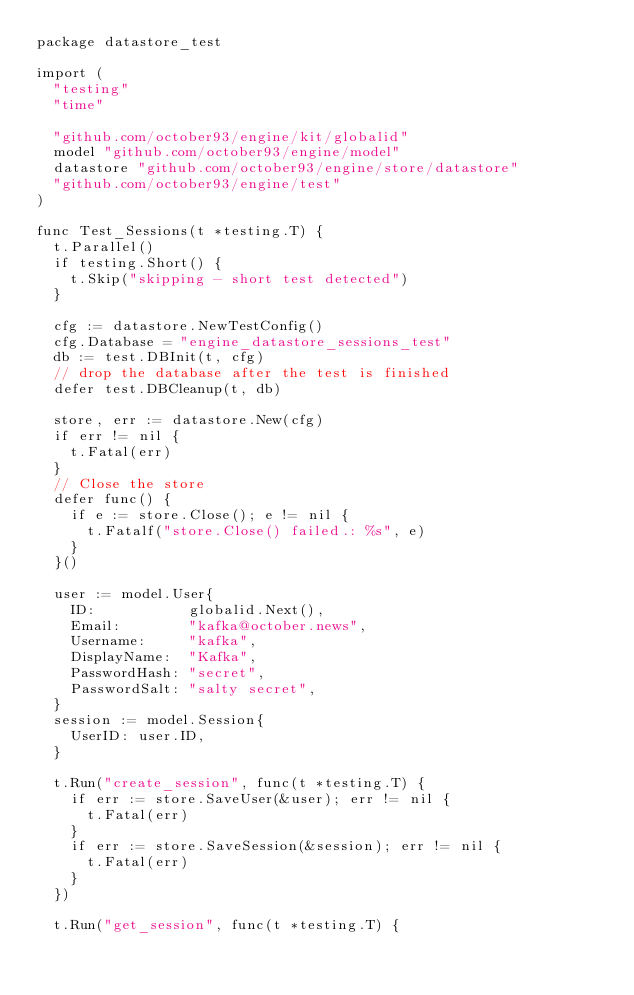<code> <loc_0><loc_0><loc_500><loc_500><_Go_>package datastore_test

import (
	"testing"
	"time"

	"github.com/october93/engine/kit/globalid"
	model "github.com/october93/engine/model"
	datastore "github.com/october93/engine/store/datastore"
	"github.com/october93/engine/test"
)

func Test_Sessions(t *testing.T) {
	t.Parallel()
	if testing.Short() {
		t.Skip("skipping - short test detected")
	}

	cfg := datastore.NewTestConfig()
	cfg.Database = "engine_datastore_sessions_test"
	db := test.DBInit(t, cfg)
	// drop the database after the test is finished
	defer test.DBCleanup(t, db)

	store, err := datastore.New(cfg)
	if err != nil {
		t.Fatal(err)
	}
	// Close the store
	defer func() {
		if e := store.Close(); e != nil {
			t.Fatalf("store.Close() failed.: %s", e)
		}
	}()

	user := model.User{
		ID:           globalid.Next(),
		Email:        "kafka@october.news",
		Username:     "kafka",
		DisplayName:  "Kafka",
		PasswordHash: "secret",
		PasswordSalt: "salty secret",
	}
	session := model.Session{
		UserID: user.ID,
	}

	t.Run("create_session", func(t *testing.T) {
		if err := store.SaveUser(&user); err != nil {
			t.Fatal(err)
		}
		if err := store.SaveSession(&session); err != nil {
			t.Fatal(err)
		}
	})

	t.Run("get_session", func(t *testing.T) {</code> 